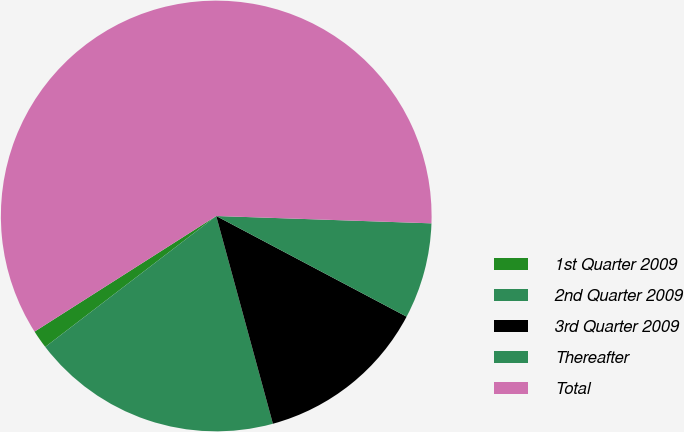<chart> <loc_0><loc_0><loc_500><loc_500><pie_chart><fcel>1st Quarter 2009<fcel>2nd Quarter 2009<fcel>3rd Quarter 2009<fcel>Thereafter<fcel>Total<nl><fcel>1.38%<fcel>18.84%<fcel>13.02%<fcel>7.2%<fcel>59.57%<nl></chart> 